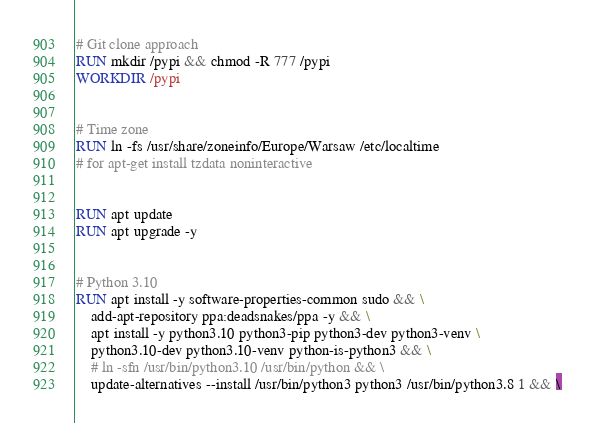Convert code to text. <code><loc_0><loc_0><loc_500><loc_500><_Dockerfile_>

# Git clone approach
RUN mkdir /pypi && chmod -R 777 /pypi
WORKDIR /pypi


# Time zone
RUN ln -fs /usr/share/zoneinfo/Europe/Warsaw /etc/localtime
# for apt-get install tzdata noninteractive


RUN apt update
RUN apt upgrade -y


# Python 3.10
RUN apt install -y software-properties-common sudo && \
    add-apt-repository ppa:deadsnakes/ppa -y && \
    apt install -y python3.10 python3-pip python3-dev python3-venv \
    python3.10-dev python3.10-venv python-is-python3 && \
    # ln -sfn /usr/bin/python3.10 /usr/bin/python && \
    update-alternatives --install /usr/bin/python3 python3 /usr/bin/python3.8 1 && \</code> 